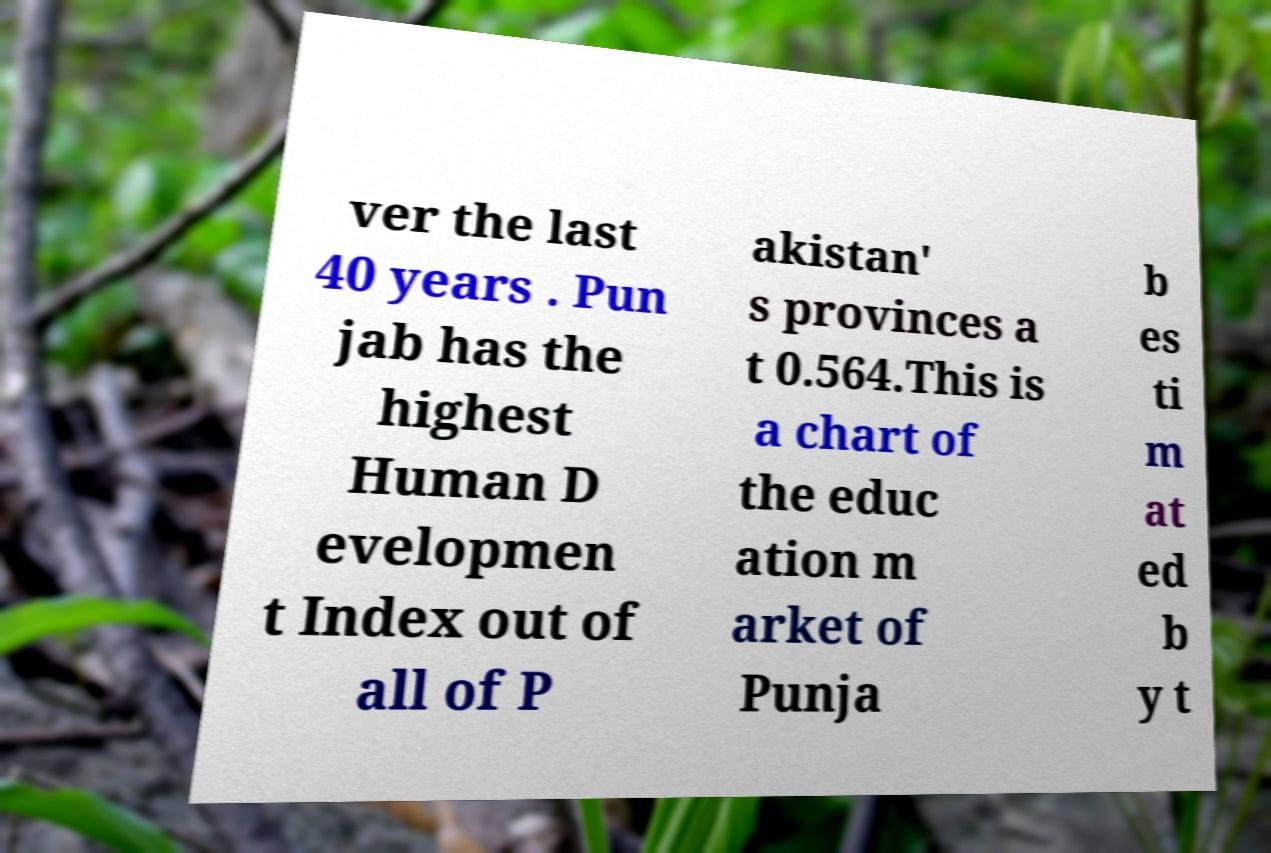What messages or text are displayed in this image? I need them in a readable, typed format. ver the last 40 years . Pun jab has the highest Human D evelopmen t Index out of all of P akistan' s provinces a t 0.564.This is a chart of the educ ation m arket of Punja b es ti m at ed b y t 